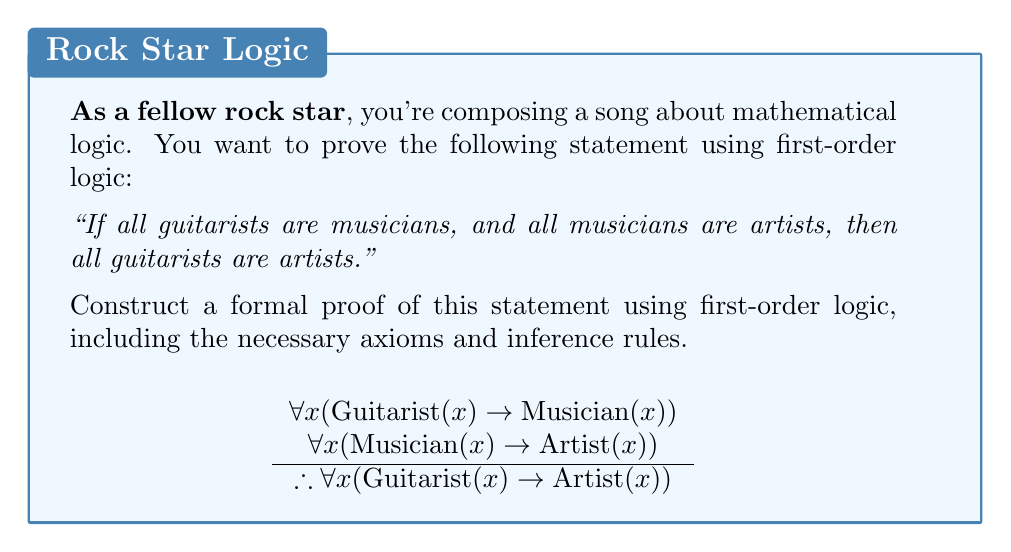What is the answer to this math problem? Let's approach this step-by-step using first-order logic:

1) First, we need to define our predicates:
   Let G(x) mean "x is a guitarist"
   Let M(x) mean "x is a musician"
   Let A(x) mean "x is an artist"

2) Now, we can formalize our premises:
   Premise 1: $\forall x (G(x) \rightarrow M(x))$
   Premise 2: $\forall x (M(x) \rightarrow A(x))$

3) Our goal is to prove: $\forall x (G(x) \rightarrow A(x))$

4) We'll use a proof by contradiction. Assume the negation of our goal:
   $\exists x (G(x) \wedge \neg A(x))$

5) Let's call this hypothetical entity 'a'. So we have:
   G(a) and $\neg$A(a)

6) From Premise 1 and G(a), we can deduce:
   M(a)

7) From Premise 2 and M(a), we can deduce:
   A(a)

8) But this contradicts $\neg$A(a) from step 5.

9) Therefore, our assumption in step 4 must be false.

10) Thus, we have proven: $\forall x (G(x) \rightarrow A(x))$

This proof uses the following rules of inference:
- Universal instantiation (steps 6 and 7)
- Modus ponens (steps 6 and 7)
- Proof by contradiction (steps 4-10)
Answer: $$\begin{align}
1. &\forall x (G(x) \rightarrow M(x)) &\text{Premise} \\
2. &\forall x (M(x) \rightarrow A(x)) &\text{Premise} \\
3. &\exists x (G(x) \wedge \neg A(x)) &\text{Assumption} \\
4. &G(a) \wedge \neg A(a) &\text{Existential Instantiation (3)} \\
5. &G(a) &\text{Simplification (4)} \\
6. &G(a) \rightarrow M(a) &\text{Universal Instantiation (1)} \\
7. &M(a) &\text{Modus Ponens (5, 6)} \\
8. &M(a) \rightarrow A(a) &\text{Universal Instantiation (2)} \\
9. &A(a) &\text{Modus Ponens (7, 8)} \\
10. &\neg A(a) &\text{Simplification (4)} \\
11. &A(a) \wedge \neg A(a) &\text{Conjunction (9, 10)} \\
12. &\neg \exists x (G(x) \wedge \neg A(x)) &\text{Proof by Contradiction (3-11)} \\
13. &\forall x (G(x) \rightarrow A(x)) &\text{Logical Equivalence (12)}
\end{align}$$ 